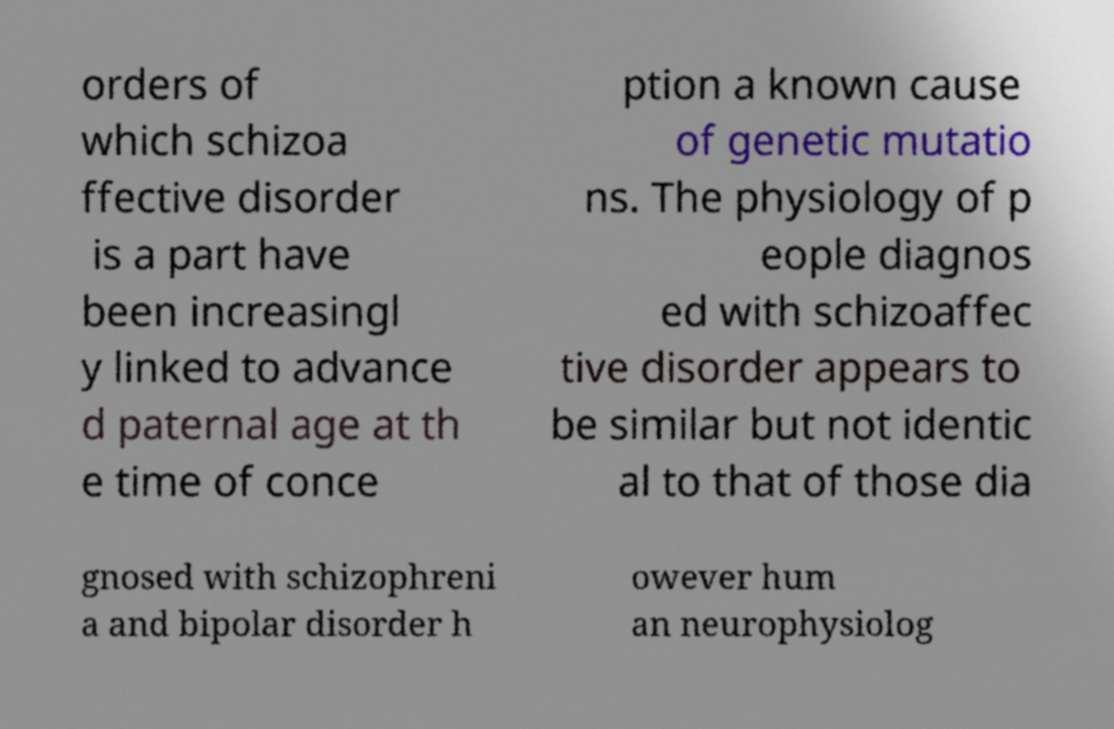Can you accurately transcribe the text from the provided image for me? orders of which schizoa ffective disorder is a part have been increasingl y linked to advance d paternal age at th e time of conce ption a known cause of genetic mutatio ns. The physiology of p eople diagnos ed with schizoaffec tive disorder appears to be similar but not identic al to that of those dia gnosed with schizophreni a and bipolar disorder h owever hum an neurophysiolog 